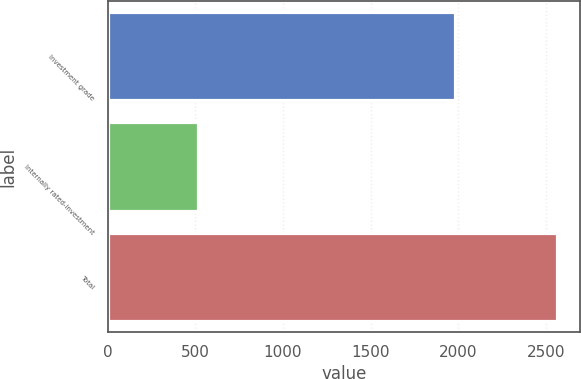Convert chart to OTSL. <chart><loc_0><loc_0><loc_500><loc_500><bar_chart><fcel>Investment grade<fcel>Internally rated-investment<fcel>Total<nl><fcel>1984<fcel>512<fcel>2565<nl></chart> 